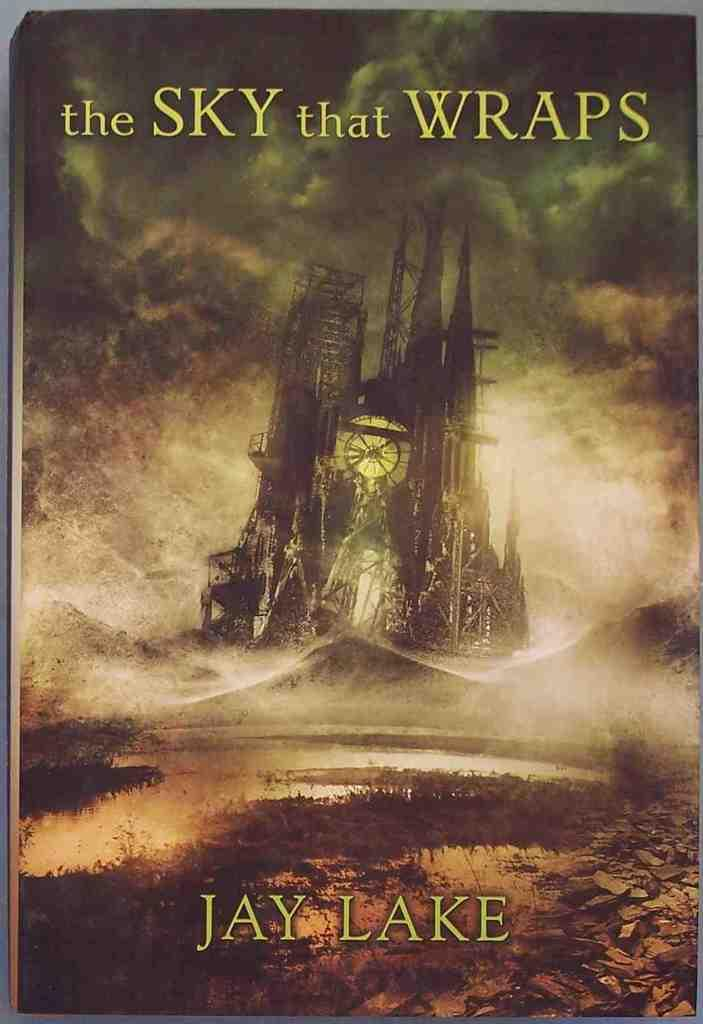<image>
Summarize the visual content of the image. A book with the title The Sky that Warps by Jay Lake with a picture of an haunting looking sky with a standing structure with a clock displayed. 